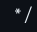<code> <loc_0><loc_0><loc_500><loc_500><_HTML_>  */</code> 